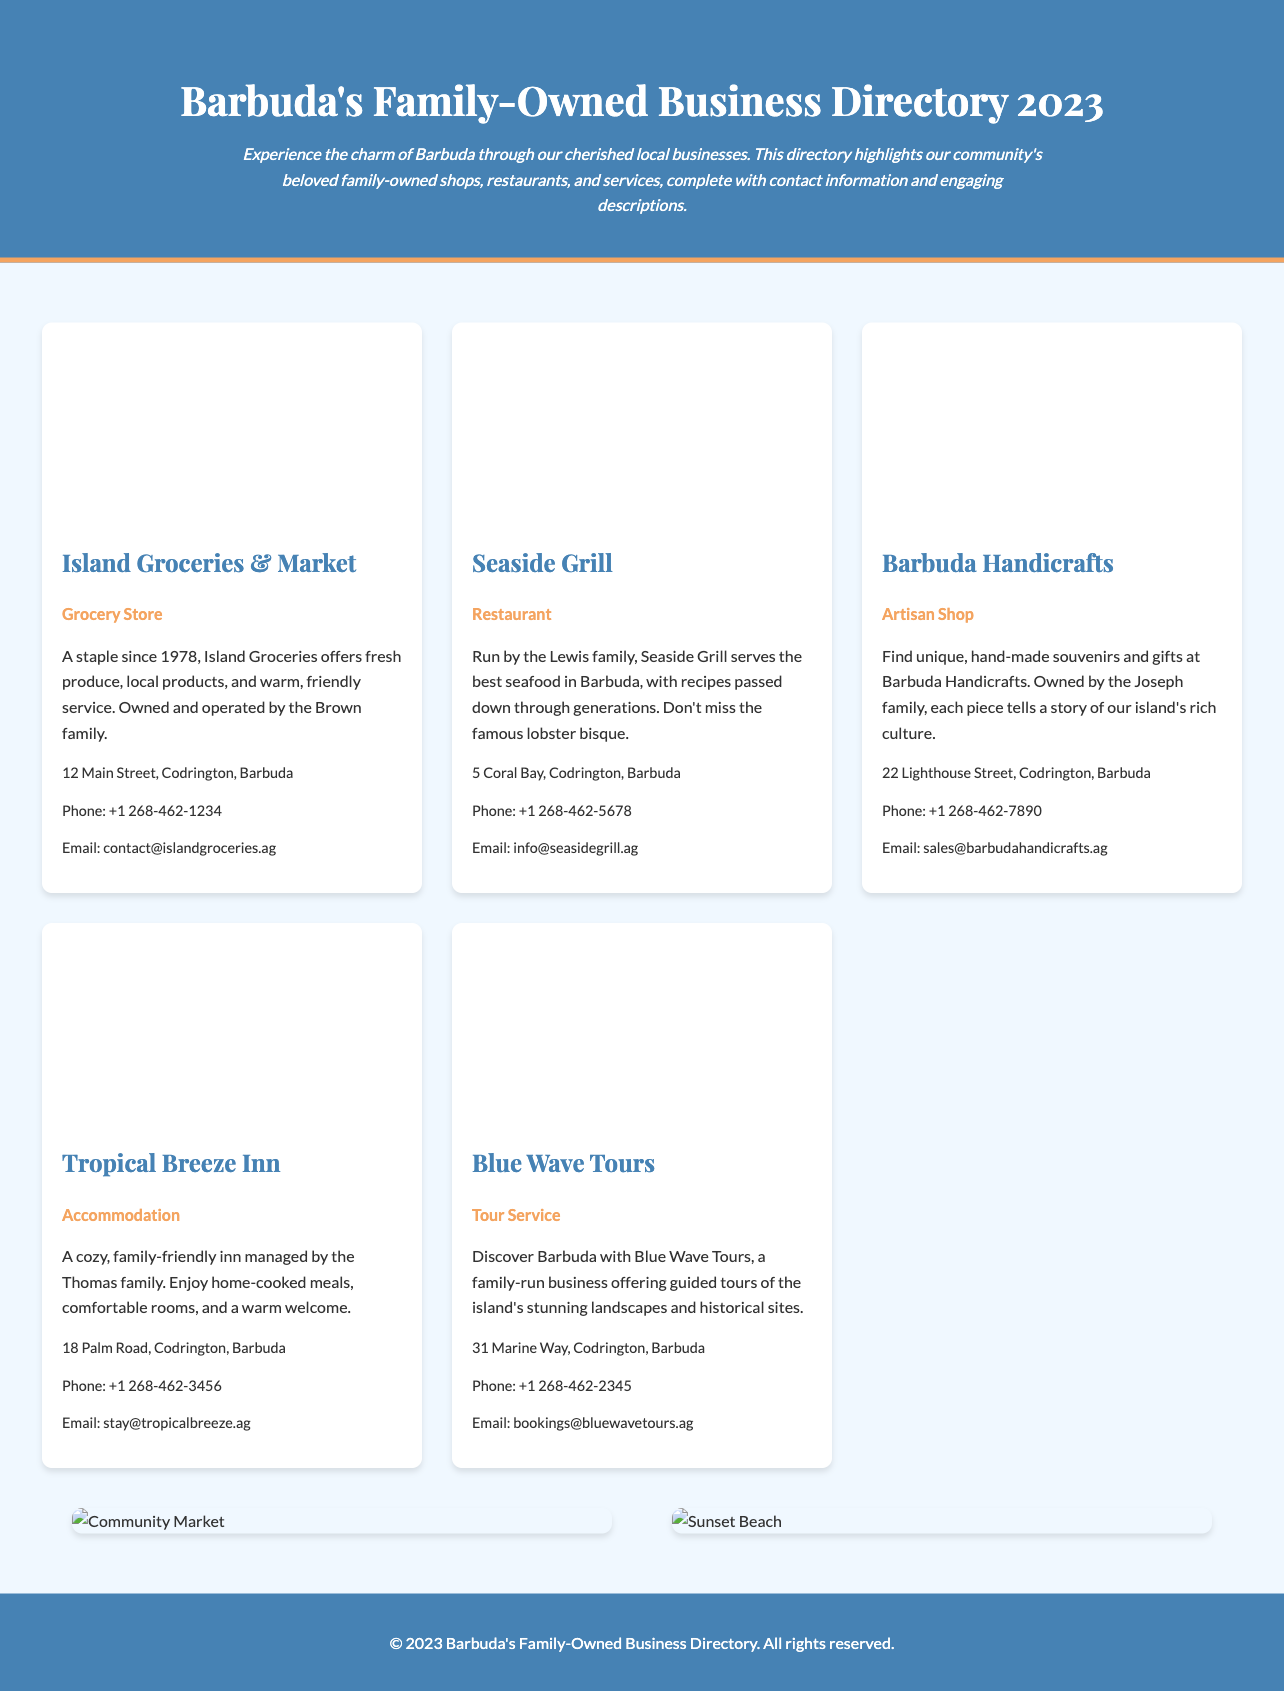What is the name of the grocery store featured? The grocery store is introduced in the document with its full name provided.
Answer: Island Groceries & Market Who operates the Seaside Grill? The document indicates the family responsible for managing the restaurant.
Answer: Lewis family What year was Island Groceries established? The document specifies the founding year of Island Groceries in its description.
Answer: 1978 How many businesses are showcased in the directory? By counting the business entries listed in the document, one can determine the total.
Answer: 5 What type of service does Blue Wave Tours provide? The document describes the primary offering of Blue Wave Tours in its business description.
Answer: Tour Service Where is Barbuda Handicrafts located? The location of Barbuda Handicrafts is provided in the contact information section of the document.
Answer: 22 Lighthouse Street, Codrington, Barbuda What is the email contact for Tropical Breeze Inn? The document contains the email address for reaching out to Tropical Breeze Inn.
Answer: stay@tropicalbreeze.ag Which business offers seafood? The nature of the offerings from Seaside Grill is detailed, making it identifiable in the document.
Answer: Seaside Grill How is the layout of the directory organized? The document describes the structure and presentation style used for the business listings.
Answer: Grid layout 